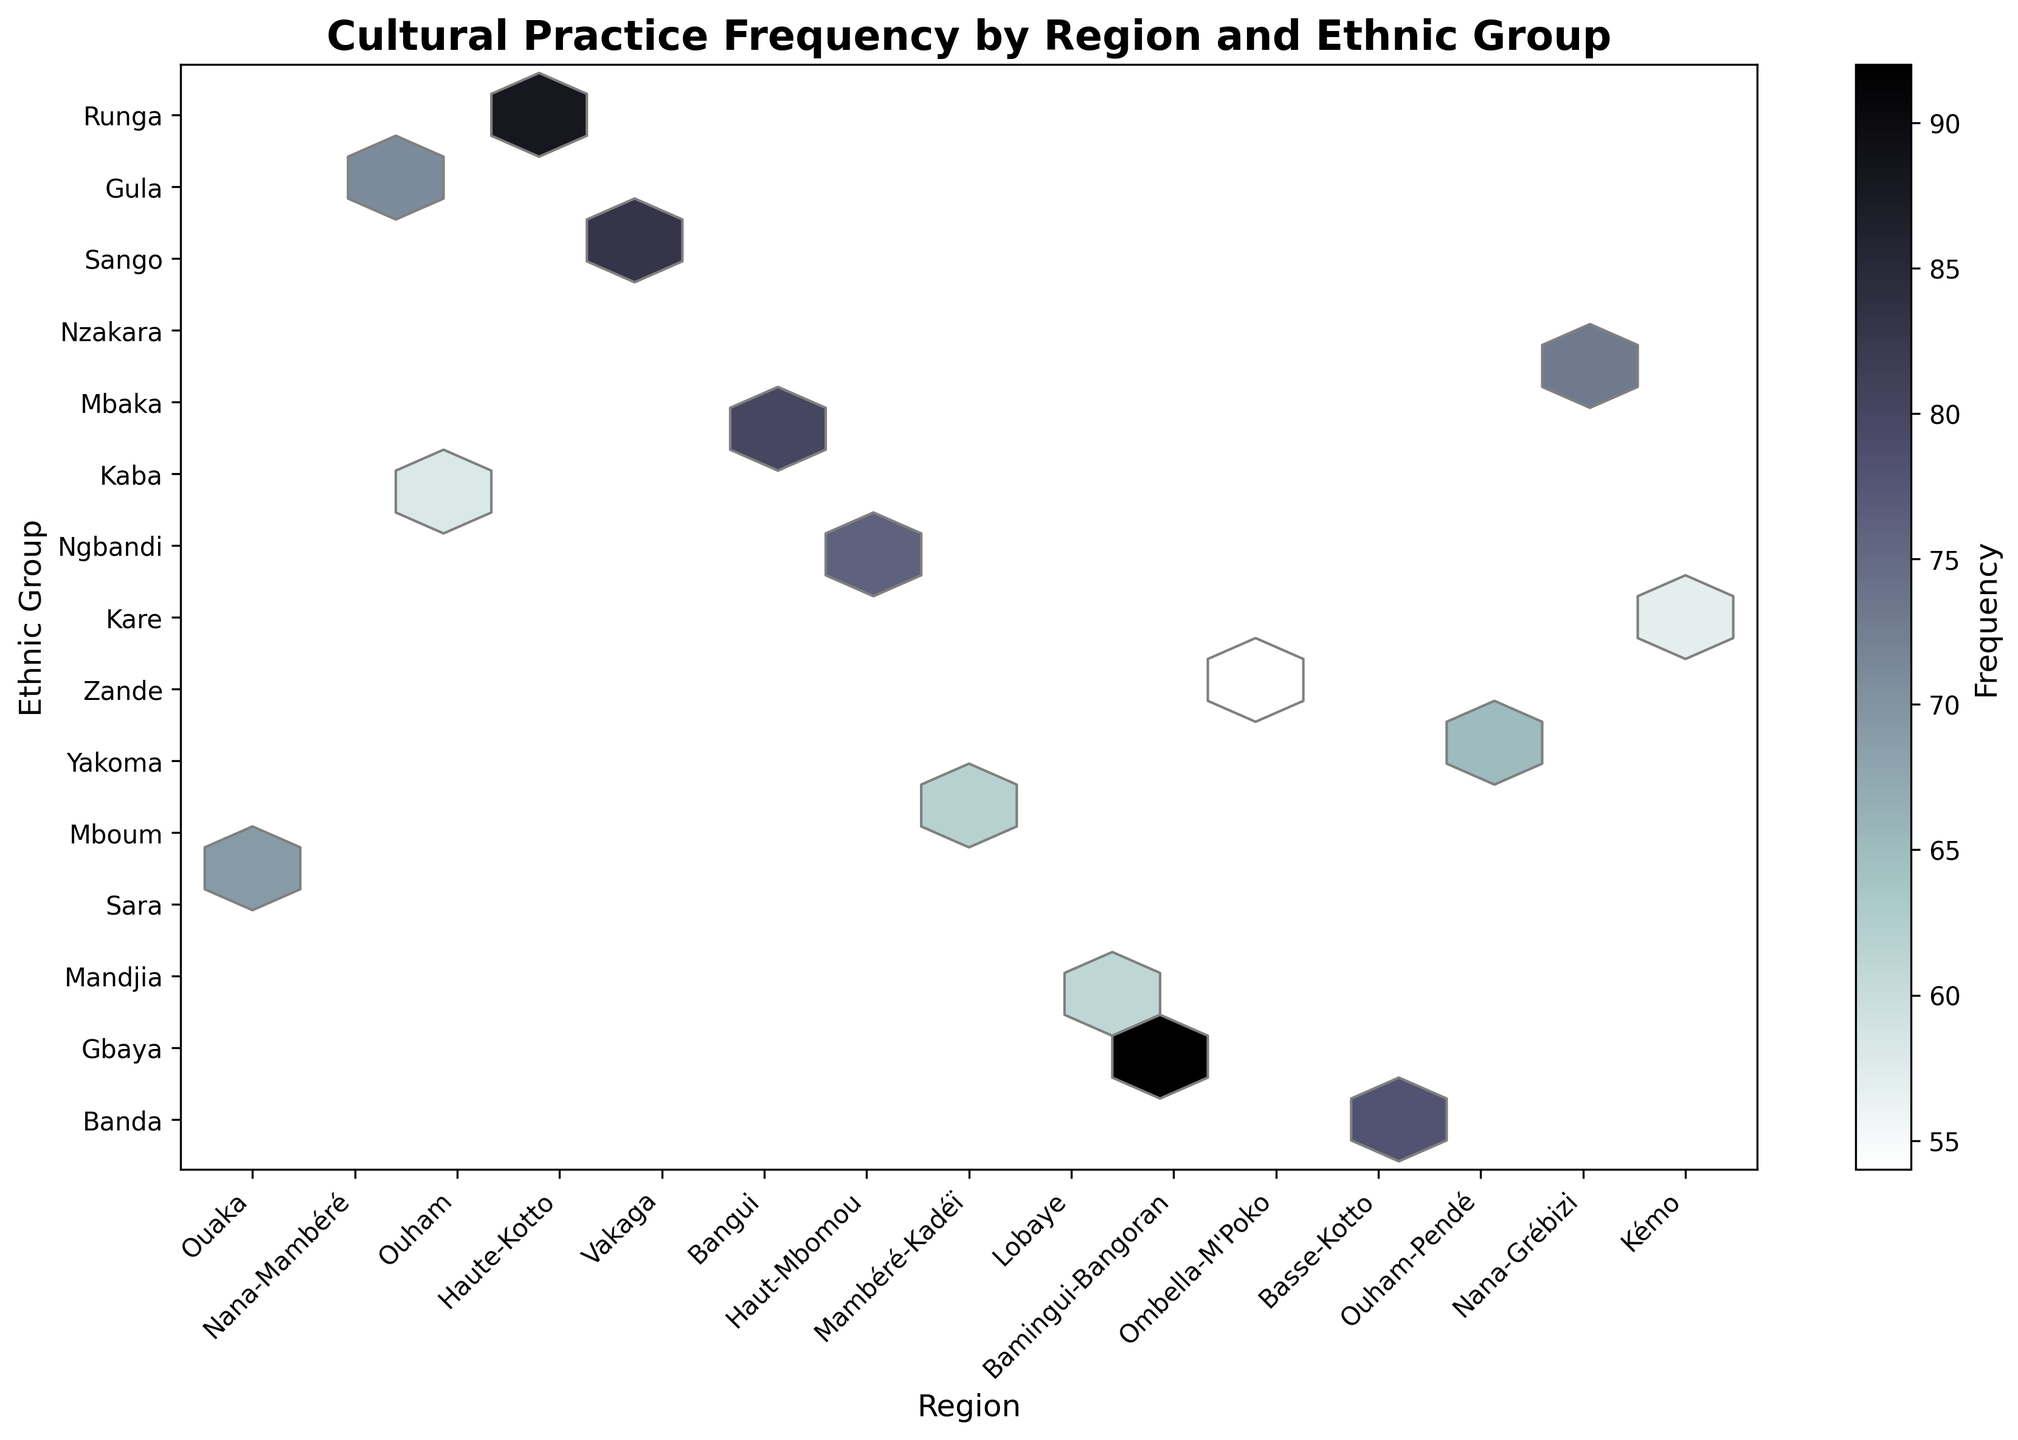How many unique regions are depicted in the plot? Count the number of unique x-axis tick labels corresponding to regions. The plot shows tick labels for each region.
Answer: 15 Which region has the highest frequency of cultural practices? Identify the region with the highest hexbin color intensity, as the color bar indicates frequency.
Answer: Nana-Mambéré Which ethnic group in the Ouaka region practices the cultural event with the highest frequency? Find the position on the hexbin plot corresponding to the Ouaka region and examine the y-axis label for the ethnic group with the highest frequency color intensity there.
Answer: Banda What is the average frequency of cultural practices for the regions shown? Sum the frequencies of all the regions and divide by the number of regions. (78 + 92 + 65 + 83 + 57 + 71 + 88 + 62 + 76 + 69 + 54 + 58 + 73 + 61 + 80) / 15.
Answer: 70 Which region and ethnic group combination has the densest grouping of data points on the plot? Look for the hexbin with the darkest color indicating the densest grouping, refer to both the x-axis for region and y-axis for ethnic group.
Answer: Ouham - Mandjia Which ethnic group practices weaving traditions? Check the y-axis label where the hexbin relates to the 'Ombella-M'Poko' region specified on the x-axis, and look for the label 'Weaving traditions' at that intersection.
Answer: Mbaka By how much does the frequency of River fishing customs practiced by the Yakoma in Bangui exceed the weaving traditions by the Mbaka in Ombella-M’Poko? Subtract the frequency of weaving traditions (54) from river fishing customs (71) to determine the difference.
Answer: 17 What is the range of frequencies for cultural practices across all ethnic groups? Determine the minimum and maximum values from the frequency data and subtract the minimum from the maximum. The range is from 54 to 92. (92 - 54)
Answer: 38 Which ethnic group has the lowest frequency of cultural practices depicted in the plot? Identify the hexbin with the lightest color intensity and refer to the corresponding ethnic group on the y-axis.
Answer: Mbaka 